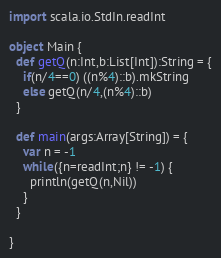Convert code to text. <code><loc_0><loc_0><loc_500><loc_500><_Scala_>import scala.io.StdIn.readInt

object Main {
  def getQ(n:Int,b:List[Int]):String = {
    if(n/4==0) ((n%4)::b).mkString
    else getQ(n/4,(n%4)::b)
  }

  def main(args:Array[String]) = {
    var n = -1
    while({n=readInt;n} != -1) {
      println(getQ(n,Nil))
    }
  }

}</code> 